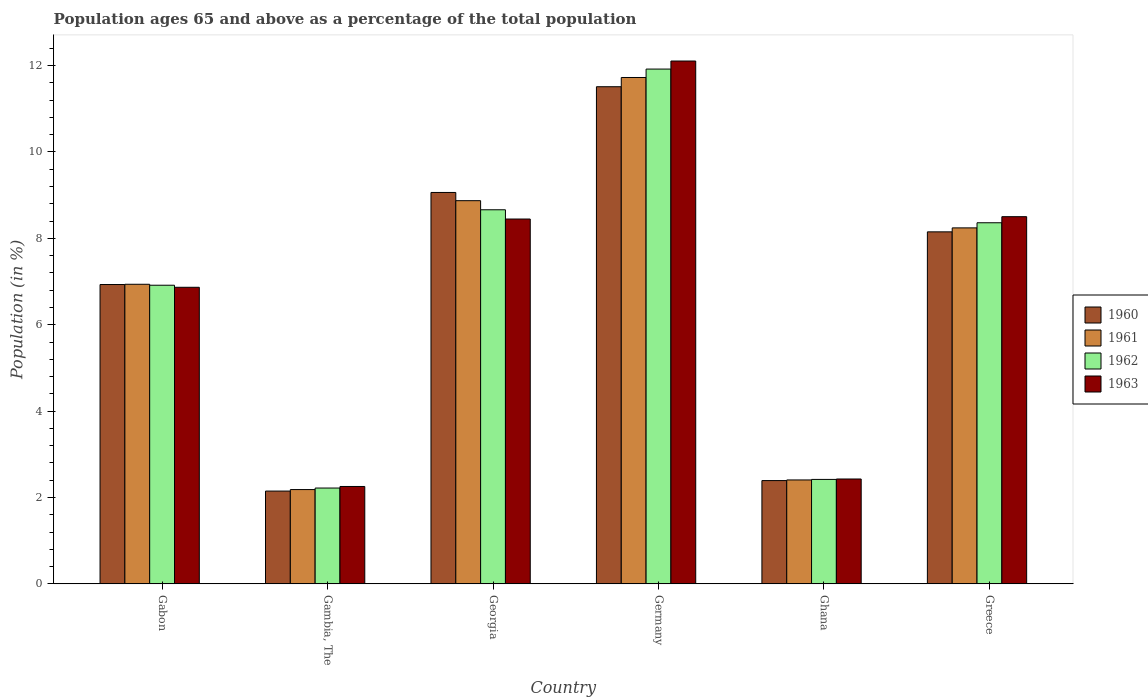Are the number of bars per tick equal to the number of legend labels?
Your response must be concise. Yes. How many bars are there on the 5th tick from the right?
Your response must be concise. 4. What is the label of the 4th group of bars from the left?
Your answer should be very brief. Germany. In how many cases, is the number of bars for a given country not equal to the number of legend labels?
Your answer should be compact. 0. What is the percentage of the population ages 65 and above in 1960 in Gambia, The?
Ensure brevity in your answer.  2.15. Across all countries, what is the maximum percentage of the population ages 65 and above in 1963?
Make the answer very short. 12.11. Across all countries, what is the minimum percentage of the population ages 65 and above in 1963?
Provide a succinct answer. 2.25. In which country was the percentage of the population ages 65 and above in 1963 minimum?
Offer a terse response. Gambia, The. What is the total percentage of the population ages 65 and above in 1960 in the graph?
Ensure brevity in your answer.  40.2. What is the difference between the percentage of the population ages 65 and above in 1960 in Gabon and that in Germany?
Provide a short and direct response. -4.58. What is the difference between the percentage of the population ages 65 and above in 1960 in Gambia, The and the percentage of the population ages 65 and above in 1962 in Ghana?
Your answer should be compact. -0.27. What is the average percentage of the population ages 65 and above in 1962 per country?
Ensure brevity in your answer.  6.75. What is the difference between the percentage of the population ages 65 and above of/in 1961 and percentage of the population ages 65 and above of/in 1962 in Ghana?
Your answer should be compact. -0.01. What is the ratio of the percentage of the population ages 65 and above in 1963 in Gabon to that in Greece?
Provide a succinct answer. 0.81. Is the percentage of the population ages 65 and above in 1961 in Georgia less than that in Ghana?
Provide a succinct answer. No. What is the difference between the highest and the second highest percentage of the population ages 65 and above in 1963?
Make the answer very short. 0.05. What is the difference between the highest and the lowest percentage of the population ages 65 and above in 1963?
Your response must be concise. 9.85. What does the 2nd bar from the left in Ghana represents?
Make the answer very short. 1961. Is it the case that in every country, the sum of the percentage of the population ages 65 and above in 1963 and percentage of the population ages 65 and above in 1962 is greater than the percentage of the population ages 65 and above in 1961?
Your answer should be very brief. Yes. How many bars are there?
Offer a very short reply. 24. How many countries are there in the graph?
Your answer should be very brief. 6. What is the difference between two consecutive major ticks on the Y-axis?
Provide a short and direct response. 2. Are the values on the major ticks of Y-axis written in scientific E-notation?
Provide a succinct answer. No. How many legend labels are there?
Your response must be concise. 4. How are the legend labels stacked?
Your answer should be very brief. Vertical. What is the title of the graph?
Offer a terse response. Population ages 65 and above as a percentage of the total population. What is the label or title of the Y-axis?
Provide a succinct answer. Population (in %). What is the Population (in %) in 1960 in Gabon?
Offer a terse response. 6.93. What is the Population (in %) in 1961 in Gabon?
Keep it short and to the point. 6.94. What is the Population (in %) of 1962 in Gabon?
Your response must be concise. 6.91. What is the Population (in %) in 1963 in Gabon?
Provide a succinct answer. 6.87. What is the Population (in %) in 1960 in Gambia, The?
Make the answer very short. 2.15. What is the Population (in %) of 1961 in Gambia, The?
Give a very brief answer. 2.18. What is the Population (in %) in 1962 in Gambia, The?
Your response must be concise. 2.22. What is the Population (in %) of 1963 in Gambia, The?
Provide a short and direct response. 2.25. What is the Population (in %) of 1960 in Georgia?
Your answer should be compact. 9.06. What is the Population (in %) of 1961 in Georgia?
Your answer should be very brief. 8.87. What is the Population (in %) in 1962 in Georgia?
Your answer should be very brief. 8.66. What is the Population (in %) of 1963 in Georgia?
Provide a short and direct response. 8.45. What is the Population (in %) of 1960 in Germany?
Give a very brief answer. 11.51. What is the Population (in %) in 1961 in Germany?
Ensure brevity in your answer.  11.73. What is the Population (in %) in 1962 in Germany?
Provide a succinct answer. 11.92. What is the Population (in %) of 1963 in Germany?
Keep it short and to the point. 12.11. What is the Population (in %) in 1960 in Ghana?
Ensure brevity in your answer.  2.39. What is the Population (in %) in 1961 in Ghana?
Ensure brevity in your answer.  2.41. What is the Population (in %) in 1962 in Ghana?
Your response must be concise. 2.42. What is the Population (in %) in 1963 in Ghana?
Keep it short and to the point. 2.43. What is the Population (in %) of 1960 in Greece?
Give a very brief answer. 8.15. What is the Population (in %) of 1961 in Greece?
Your answer should be compact. 8.24. What is the Population (in %) of 1962 in Greece?
Ensure brevity in your answer.  8.36. What is the Population (in %) in 1963 in Greece?
Offer a very short reply. 8.5. Across all countries, what is the maximum Population (in %) of 1960?
Ensure brevity in your answer.  11.51. Across all countries, what is the maximum Population (in %) in 1961?
Provide a succinct answer. 11.73. Across all countries, what is the maximum Population (in %) of 1962?
Offer a very short reply. 11.92. Across all countries, what is the maximum Population (in %) of 1963?
Offer a very short reply. 12.11. Across all countries, what is the minimum Population (in %) of 1960?
Provide a short and direct response. 2.15. Across all countries, what is the minimum Population (in %) of 1961?
Keep it short and to the point. 2.18. Across all countries, what is the minimum Population (in %) in 1962?
Your response must be concise. 2.22. Across all countries, what is the minimum Population (in %) in 1963?
Provide a succinct answer. 2.25. What is the total Population (in %) of 1960 in the graph?
Your answer should be very brief. 40.2. What is the total Population (in %) in 1961 in the graph?
Give a very brief answer. 40.37. What is the total Population (in %) of 1962 in the graph?
Your answer should be very brief. 40.5. What is the total Population (in %) of 1963 in the graph?
Ensure brevity in your answer.  40.61. What is the difference between the Population (in %) of 1960 in Gabon and that in Gambia, The?
Your answer should be compact. 4.78. What is the difference between the Population (in %) of 1961 in Gabon and that in Gambia, The?
Offer a terse response. 4.75. What is the difference between the Population (in %) of 1962 in Gabon and that in Gambia, The?
Your answer should be very brief. 4.7. What is the difference between the Population (in %) in 1963 in Gabon and that in Gambia, The?
Ensure brevity in your answer.  4.61. What is the difference between the Population (in %) in 1960 in Gabon and that in Georgia?
Ensure brevity in your answer.  -2.13. What is the difference between the Population (in %) of 1961 in Gabon and that in Georgia?
Provide a short and direct response. -1.94. What is the difference between the Population (in %) in 1962 in Gabon and that in Georgia?
Your answer should be very brief. -1.75. What is the difference between the Population (in %) in 1963 in Gabon and that in Georgia?
Offer a terse response. -1.58. What is the difference between the Population (in %) in 1960 in Gabon and that in Germany?
Provide a short and direct response. -4.58. What is the difference between the Population (in %) of 1961 in Gabon and that in Germany?
Offer a very short reply. -4.79. What is the difference between the Population (in %) in 1962 in Gabon and that in Germany?
Your response must be concise. -5.01. What is the difference between the Population (in %) in 1963 in Gabon and that in Germany?
Make the answer very short. -5.24. What is the difference between the Population (in %) in 1960 in Gabon and that in Ghana?
Provide a short and direct response. 4.54. What is the difference between the Population (in %) of 1961 in Gabon and that in Ghana?
Your answer should be very brief. 4.53. What is the difference between the Population (in %) of 1962 in Gabon and that in Ghana?
Give a very brief answer. 4.5. What is the difference between the Population (in %) in 1963 in Gabon and that in Ghana?
Offer a terse response. 4.44. What is the difference between the Population (in %) of 1960 in Gabon and that in Greece?
Your answer should be very brief. -1.22. What is the difference between the Population (in %) of 1961 in Gabon and that in Greece?
Give a very brief answer. -1.31. What is the difference between the Population (in %) of 1962 in Gabon and that in Greece?
Offer a very short reply. -1.45. What is the difference between the Population (in %) of 1963 in Gabon and that in Greece?
Provide a short and direct response. -1.64. What is the difference between the Population (in %) of 1960 in Gambia, The and that in Georgia?
Offer a very short reply. -6.91. What is the difference between the Population (in %) in 1961 in Gambia, The and that in Georgia?
Provide a short and direct response. -6.69. What is the difference between the Population (in %) of 1962 in Gambia, The and that in Georgia?
Make the answer very short. -6.44. What is the difference between the Population (in %) in 1963 in Gambia, The and that in Georgia?
Your answer should be compact. -6.19. What is the difference between the Population (in %) in 1960 in Gambia, The and that in Germany?
Offer a very short reply. -9.36. What is the difference between the Population (in %) of 1961 in Gambia, The and that in Germany?
Keep it short and to the point. -9.54. What is the difference between the Population (in %) of 1962 in Gambia, The and that in Germany?
Provide a succinct answer. -9.7. What is the difference between the Population (in %) in 1963 in Gambia, The and that in Germany?
Your answer should be very brief. -9.85. What is the difference between the Population (in %) of 1960 in Gambia, The and that in Ghana?
Your answer should be very brief. -0.24. What is the difference between the Population (in %) of 1961 in Gambia, The and that in Ghana?
Give a very brief answer. -0.22. What is the difference between the Population (in %) of 1962 in Gambia, The and that in Ghana?
Offer a terse response. -0.2. What is the difference between the Population (in %) of 1963 in Gambia, The and that in Ghana?
Your answer should be compact. -0.17. What is the difference between the Population (in %) of 1960 in Gambia, The and that in Greece?
Provide a succinct answer. -6. What is the difference between the Population (in %) in 1961 in Gambia, The and that in Greece?
Make the answer very short. -6.06. What is the difference between the Population (in %) of 1962 in Gambia, The and that in Greece?
Offer a very short reply. -6.14. What is the difference between the Population (in %) of 1963 in Gambia, The and that in Greece?
Make the answer very short. -6.25. What is the difference between the Population (in %) of 1960 in Georgia and that in Germany?
Provide a short and direct response. -2.45. What is the difference between the Population (in %) of 1961 in Georgia and that in Germany?
Your answer should be very brief. -2.85. What is the difference between the Population (in %) in 1962 in Georgia and that in Germany?
Offer a very short reply. -3.26. What is the difference between the Population (in %) of 1963 in Georgia and that in Germany?
Make the answer very short. -3.66. What is the difference between the Population (in %) in 1960 in Georgia and that in Ghana?
Give a very brief answer. 6.67. What is the difference between the Population (in %) in 1961 in Georgia and that in Ghana?
Your answer should be compact. 6.47. What is the difference between the Population (in %) in 1962 in Georgia and that in Ghana?
Your response must be concise. 6.24. What is the difference between the Population (in %) of 1963 in Georgia and that in Ghana?
Keep it short and to the point. 6.02. What is the difference between the Population (in %) in 1960 in Georgia and that in Greece?
Provide a short and direct response. 0.91. What is the difference between the Population (in %) in 1961 in Georgia and that in Greece?
Make the answer very short. 0.63. What is the difference between the Population (in %) of 1962 in Georgia and that in Greece?
Give a very brief answer. 0.3. What is the difference between the Population (in %) of 1963 in Georgia and that in Greece?
Your answer should be very brief. -0.05. What is the difference between the Population (in %) in 1960 in Germany and that in Ghana?
Offer a terse response. 9.12. What is the difference between the Population (in %) in 1961 in Germany and that in Ghana?
Keep it short and to the point. 9.32. What is the difference between the Population (in %) in 1962 in Germany and that in Ghana?
Give a very brief answer. 9.5. What is the difference between the Population (in %) in 1963 in Germany and that in Ghana?
Ensure brevity in your answer.  9.68. What is the difference between the Population (in %) in 1960 in Germany and that in Greece?
Your response must be concise. 3.36. What is the difference between the Population (in %) of 1961 in Germany and that in Greece?
Offer a terse response. 3.48. What is the difference between the Population (in %) of 1962 in Germany and that in Greece?
Your response must be concise. 3.56. What is the difference between the Population (in %) in 1963 in Germany and that in Greece?
Provide a short and direct response. 3.6. What is the difference between the Population (in %) in 1960 in Ghana and that in Greece?
Your response must be concise. -5.76. What is the difference between the Population (in %) of 1961 in Ghana and that in Greece?
Provide a succinct answer. -5.84. What is the difference between the Population (in %) of 1962 in Ghana and that in Greece?
Your response must be concise. -5.94. What is the difference between the Population (in %) in 1963 in Ghana and that in Greece?
Your answer should be compact. -6.07. What is the difference between the Population (in %) in 1960 in Gabon and the Population (in %) in 1961 in Gambia, The?
Make the answer very short. 4.75. What is the difference between the Population (in %) in 1960 in Gabon and the Population (in %) in 1962 in Gambia, The?
Offer a very short reply. 4.71. What is the difference between the Population (in %) in 1960 in Gabon and the Population (in %) in 1963 in Gambia, The?
Your answer should be very brief. 4.68. What is the difference between the Population (in %) in 1961 in Gabon and the Population (in %) in 1962 in Gambia, The?
Provide a short and direct response. 4.72. What is the difference between the Population (in %) of 1961 in Gabon and the Population (in %) of 1963 in Gambia, The?
Offer a terse response. 4.68. What is the difference between the Population (in %) in 1962 in Gabon and the Population (in %) in 1963 in Gambia, The?
Your answer should be compact. 4.66. What is the difference between the Population (in %) of 1960 in Gabon and the Population (in %) of 1961 in Georgia?
Offer a very short reply. -1.94. What is the difference between the Population (in %) in 1960 in Gabon and the Population (in %) in 1962 in Georgia?
Your answer should be compact. -1.73. What is the difference between the Population (in %) in 1960 in Gabon and the Population (in %) in 1963 in Georgia?
Keep it short and to the point. -1.52. What is the difference between the Population (in %) in 1961 in Gabon and the Population (in %) in 1962 in Georgia?
Your answer should be compact. -1.73. What is the difference between the Population (in %) in 1961 in Gabon and the Population (in %) in 1963 in Georgia?
Your response must be concise. -1.51. What is the difference between the Population (in %) in 1962 in Gabon and the Population (in %) in 1963 in Georgia?
Ensure brevity in your answer.  -1.53. What is the difference between the Population (in %) in 1960 in Gabon and the Population (in %) in 1961 in Germany?
Ensure brevity in your answer.  -4.79. What is the difference between the Population (in %) in 1960 in Gabon and the Population (in %) in 1962 in Germany?
Offer a very short reply. -4.99. What is the difference between the Population (in %) in 1960 in Gabon and the Population (in %) in 1963 in Germany?
Your answer should be very brief. -5.18. What is the difference between the Population (in %) of 1961 in Gabon and the Population (in %) of 1962 in Germany?
Provide a short and direct response. -4.98. What is the difference between the Population (in %) of 1961 in Gabon and the Population (in %) of 1963 in Germany?
Keep it short and to the point. -5.17. What is the difference between the Population (in %) of 1962 in Gabon and the Population (in %) of 1963 in Germany?
Keep it short and to the point. -5.19. What is the difference between the Population (in %) in 1960 in Gabon and the Population (in %) in 1961 in Ghana?
Provide a succinct answer. 4.53. What is the difference between the Population (in %) of 1960 in Gabon and the Population (in %) of 1962 in Ghana?
Offer a very short reply. 4.51. What is the difference between the Population (in %) in 1960 in Gabon and the Population (in %) in 1963 in Ghana?
Ensure brevity in your answer.  4.5. What is the difference between the Population (in %) of 1961 in Gabon and the Population (in %) of 1962 in Ghana?
Provide a short and direct response. 4.52. What is the difference between the Population (in %) of 1961 in Gabon and the Population (in %) of 1963 in Ghana?
Provide a short and direct response. 4.51. What is the difference between the Population (in %) in 1962 in Gabon and the Population (in %) in 1963 in Ghana?
Your response must be concise. 4.49. What is the difference between the Population (in %) of 1960 in Gabon and the Population (in %) of 1961 in Greece?
Offer a terse response. -1.31. What is the difference between the Population (in %) in 1960 in Gabon and the Population (in %) in 1962 in Greece?
Ensure brevity in your answer.  -1.43. What is the difference between the Population (in %) of 1960 in Gabon and the Population (in %) of 1963 in Greece?
Give a very brief answer. -1.57. What is the difference between the Population (in %) in 1961 in Gabon and the Population (in %) in 1962 in Greece?
Keep it short and to the point. -1.42. What is the difference between the Population (in %) of 1961 in Gabon and the Population (in %) of 1963 in Greece?
Keep it short and to the point. -1.57. What is the difference between the Population (in %) in 1962 in Gabon and the Population (in %) in 1963 in Greece?
Keep it short and to the point. -1.59. What is the difference between the Population (in %) of 1960 in Gambia, The and the Population (in %) of 1961 in Georgia?
Give a very brief answer. -6.72. What is the difference between the Population (in %) of 1960 in Gambia, The and the Population (in %) of 1962 in Georgia?
Keep it short and to the point. -6.51. What is the difference between the Population (in %) of 1960 in Gambia, The and the Population (in %) of 1963 in Georgia?
Offer a very short reply. -6.3. What is the difference between the Population (in %) in 1961 in Gambia, The and the Population (in %) in 1962 in Georgia?
Provide a succinct answer. -6.48. What is the difference between the Population (in %) of 1961 in Gambia, The and the Population (in %) of 1963 in Georgia?
Make the answer very short. -6.26. What is the difference between the Population (in %) in 1962 in Gambia, The and the Population (in %) in 1963 in Georgia?
Offer a very short reply. -6.23. What is the difference between the Population (in %) in 1960 in Gambia, The and the Population (in %) in 1961 in Germany?
Make the answer very short. -9.58. What is the difference between the Population (in %) in 1960 in Gambia, The and the Population (in %) in 1962 in Germany?
Keep it short and to the point. -9.77. What is the difference between the Population (in %) of 1960 in Gambia, The and the Population (in %) of 1963 in Germany?
Your answer should be very brief. -9.96. What is the difference between the Population (in %) of 1961 in Gambia, The and the Population (in %) of 1962 in Germany?
Give a very brief answer. -9.74. What is the difference between the Population (in %) of 1961 in Gambia, The and the Population (in %) of 1963 in Germany?
Your answer should be very brief. -9.92. What is the difference between the Population (in %) of 1962 in Gambia, The and the Population (in %) of 1963 in Germany?
Offer a terse response. -9.89. What is the difference between the Population (in %) in 1960 in Gambia, The and the Population (in %) in 1961 in Ghana?
Your answer should be compact. -0.26. What is the difference between the Population (in %) of 1960 in Gambia, The and the Population (in %) of 1962 in Ghana?
Offer a terse response. -0.27. What is the difference between the Population (in %) of 1960 in Gambia, The and the Population (in %) of 1963 in Ghana?
Your response must be concise. -0.28. What is the difference between the Population (in %) of 1961 in Gambia, The and the Population (in %) of 1962 in Ghana?
Your response must be concise. -0.24. What is the difference between the Population (in %) in 1961 in Gambia, The and the Population (in %) in 1963 in Ghana?
Provide a short and direct response. -0.24. What is the difference between the Population (in %) in 1962 in Gambia, The and the Population (in %) in 1963 in Ghana?
Make the answer very short. -0.21. What is the difference between the Population (in %) in 1960 in Gambia, The and the Population (in %) in 1961 in Greece?
Make the answer very short. -6.09. What is the difference between the Population (in %) of 1960 in Gambia, The and the Population (in %) of 1962 in Greece?
Provide a succinct answer. -6.21. What is the difference between the Population (in %) in 1960 in Gambia, The and the Population (in %) in 1963 in Greece?
Offer a terse response. -6.35. What is the difference between the Population (in %) in 1961 in Gambia, The and the Population (in %) in 1962 in Greece?
Ensure brevity in your answer.  -6.18. What is the difference between the Population (in %) in 1961 in Gambia, The and the Population (in %) in 1963 in Greece?
Give a very brief answer. -6.32. What is the difference between the Population (in %) in 1962 in Gambia, The and the Population (in %) in 1963 in Greece?
Provide a succinct answer. -6.28. What is the difference between the Population (in %) of 1960 in Georgia and the Population (in %) of 1961 in Germany?
Give a very brief answer. -2.66. What is the difference between the Population (in %) in 1960 in Georgia and the Population (in %) in 1962 in Germany?
Your response must be concise. -2.86. What is the difference between the Population (in %) of 1960 in Georgia and the Population (in %) of 1963 in Germany?
Provide a short and direct response. -3.04. What is the difference between the Population (in %) in 1961 in Georgia and the Population (in %) in 1962 in Germany?
Ensure brevity in your answer.  -3.05. What is the difference between the Population (in %) of 1961 in Georgia and the Population (in %) of 1963 in Germany?
Offer a very short reply. -3.23. What is the difference between the Population (in %) of 1962 in Georgia and the Population (in %) of 1963 in Germany?
Provide a short and direct response. -3.44. What is the difference between the Population (in %) of 1960 in Georgia and the Population (in %) of 1961 in Ghana?
Ensure brevity in your answer.  6.66. What is the difference between the Population (in %) of 1960 in Georgia and the Population (in %) of 1962 in Ghana?
Keep it short and to the point. 6.64. What is the difference between the Population (in %) in 1960 in Georgia and the Population (in %) in 1963 in Ghana?
Offer a very short reply. 6.63. What is the difference between the Population (in %) in 1961 in Georgia and the Population (in %) in 1962 in Ghana?
Offer a terse response. 6.45. What is the difference between the Population (in %) in 1961 in Georgia and the Population (in %) in 1963 in Ghana?
Provide a short and direct response. 6.44. What is the difference between the Population (in %) of 1962 in Georgia and the Population (in %) of 1963 in Ghana?
Offer a very short reply. 6.23. What is the difference between the Population (in %) of 1960 in Georgia and the Population (in %) of 1961 in Greece?
Provide a short and direct response. 0.82. What is the difference between the Population (in %) of 1960 in Georgia and the Population (in %) of 1962 in Greece?
Ensure brevity in your answer.  0.7. What is the difference between the Population (in %) in 1960 in Georgia and the Population (in %) in 1963 in Greece?
Provide a succinct answer. 0.56. What is the difference between the Population (in %) of 1961 in Georgia and the Population (in %) of 1962 in Greece?
Ensure brevity in your answer.  0.51. What is the difference between the Population (in %) in 1961 in Georgia and the Population (in %) in 1963 in Greece?
Provide a succinct answer. 0.37. What is the difference between the Population (in %) in 1962 in Georgia and the Population (in %) in 1963 in Greece?
Provide a short and direct response. 0.16. What is the difference between the Population (in %) in 1960 in Germany and the Population (in %) in 1961 in Ghana?
Offer a very short reply. 9.11. What is the difference between the Population (in %) in 1960 in Germany and the Population (in %) in 1962 in Ghana?
Provide a succinct answer. 9.09. What is the difference between the Population (in %) of 1960 in Germany and the Population (in %) of 1963 in Ghana?
Give a very brief answer. 9.08. What is the difference between the Population (in %) in 1961 in Germany and the Population (in %) in 1962 in Ghana?
Your response must be concise. 9.31. What is the difference between the Population (in %) in 1961 in Germany and the Population (in %) in 1963 in Ghana?
Your answer should be compact. 9.3. What is the difference between the Population (in %) of 1962 in Germany and the Population (in %) of 1963 in Ghana?
Offer a very short reply. 9.49. What is the difference between the Population (in %) of 1960 in Germany and the Population (in %) of 1961 in Greece?
Your answer should be very brief. 3.27. What is the difference between the Population (in %) in 1960 in Germany and the Population (in %) in 1962 in Greece?
Provide a short and direct response. 3.15. What is the difference between the Population (in %) of 1960 in Germany and the Population (in %) of 1963 in Greece?
Your response must be concise. 3.01. What is the difference between the Population (in %) in 1961 in Germany and the Population (in %) in 1962 in Greece?
Provide a succinct answer. 3.36. What is the difference between the Population (in %) of 1961 in Germany and the Population (in %) of 1963 in Greece?
Provide a short and direct response. 3.22. What is the difference between the Population (in %) in 1962 in Germany and the Population (in %) in 1963 in Greece?
Provide a short and direct response. 3.42. What is the difference between the Population (in %) of 1960 in Ghana and the Population (in %) of 1961 in Greece?
Keep it short and to the point. -5.85. What is the difference between the Population (in %) in 1960 in Ghana and the Population (in %) in 1962 in Greece?
Your response must be concise. -5.97. What is the difference between the Population (in %) of 1960 in Ghana and the Population (in %) of 1963 in Greece?
Keep it short and to the point. -6.11. What is the difference between the Population (in %) of 1961 in Ghana and the Population (in %) of 1962 in Greece?
Your response must be concise. -5.96. What is the difference between the Population (in %) in 1961 in Ghana and the Population (in %) in 1963 in Greece?
Offer a terse response. -6.1. What is the difference between the Population (in %) of 1962 in Ghana and the Population (in %) of 1963 in Greece?
Provide a succinct answer. -6.08. What is the average Population (in %) of 1960 per country?
Provide a succinct answer. 6.7. What is the average Population (in %) in 1961 per country?
Keep it short and to the point. 6.73. What is the average Population (in %) in 1962 per country?
Your answer should be very brief. 6.75. What is the average Population (in %) in 1963 per country?
Your answer should be very brief. 6.77. What is the difference between the Population (in %) in 1960 and Population (in %) in 1961 in Gabon?
Ensure brevity in your answer.  -0.01. What is the difference between the Population (in %) in 1960 and Population (in %) in 1962 in Gabon?
Your answer should be very brief. 0.02. What is the difference between the Population (in %) in 1960 and Population (in %) in 1963 in Gabon?
Keep it short and to the point. 0.06. What is the difference between the Population (in %) in 1961 and Population (in %) in 1962 in Gabon?
Offer a terse response. 0.02. What is the difference between the Population (in %) in 1961 and Population (in %) in 1963 in Gabon?
Keep it short and to the point. 0.07. What is the difference between the Population (in %) in 1962 and Population (in %) in 1963 in Gabon?
Ensure brevity in your answer.  0.05. What is the difference between the Population (in %) in 1960 and Population (in %) in 1961 in Gambia, The?
Ensure brevity in your answer.  -0.03. What is the difference between the Population (in %) in 1960 and Population (in %) in 1962 in Gambia, The?
Your answer should be compact. -0.07. What is the difference between the Population (in %) in 1960 and Population (in %) in 1963 in Gambia, The?
Offer a very short reply. -0.11. What is the difference between the Population (in %) of 1961 and Population (in %) of 1962 in Gambia, The?
Give a very brief answer. -0.04. What is the difference between the Population (in %) of 1961 and Population (in %) of 1963 in Gambia, The?
Provide a succinct answer. -0.07. What is the difference between the Population (in %) in 1962 and Population (in %) in 1963 in Gambia, The?
Make the answer very short. -0.04. What is the difference between the Population (in %) in 1960 and Population (in %) in 1961 in Georgia?
Offer a very short reply. 0.19. What is the difference between the Population (in %) of 1960 and Population (in %) of 1962 in Georgia?
Ensure brevity in your answer.  0.4. What is the difference between the Population (in %) of 1960 and Population (in %) of 1963 in Georgia?
Your answer should be very brief. 0.61. What is the difference between the Population (in %) of 1961 and Population (in %) of 1962 in Georgia?
Ensure brevity in your answer.  0.21. What is the difference between the Population (in %) in 1961 and Population (in %) in 1963 in Georgia?
Give a very brief answer. 0.42. What is the difference between the Population (in %) of 1962 and Population (in %) of 1963 in Georgia?
Provide a succinct answer. 0.21. What is the difference between the Population (in %) of 1960 and Population (in %) of 1961 in Germany?
Provide a short and direct response. -0.21. What is the difference between the Population (in %) of 1960 and Population (in %) of 1962 in Germany?
Keep it short and to the point. -0.41. What is the difference between the Population (in %) of 1960 and Population (in %) of 1963 in Germany?
Make the answer very short. -0.6. What is the difference between the Population (in %) in 1961 and Population (in %) in 1962 in Germany?
Provide a succinct answer. -0.2. What is the difference between the Population (in %) of 1961 and Population (in %) of 1963 in Germany?
Provide a short and direct response. -0.38. What is the difference between the Population (in %) of 1962 and Population (in %) of 1963 in Germany?
Offer a terse response. -0.19. What is the difference between the Population (in %) in 1960 and Population (in %) in 1961 in Ghana?
Your answer should be compact. -0.01. What is the difference between the Population (in %) in 1960 and Population (in %) in 1962 in Ghana?
Ensure brevity in your answer.  -0.03. What is the difference between the Population (in %) in 1960 and Population (in %) in 1963 in Ghana?
Give a very brief answer. -0.04. What is the difference between the Population (in %) of 1961 and Population (in %) of 1962 in Ghana?
Your response must be concise. -0.01. What is the difference between the Population (in %) in 1961 and Population (in %) in 1963 in Ghana?
Ensure brevity in your answer.  -0.02. What is the difference between the Population (in %) of 1962 and Population (in %) of 1963 in Ghana?
Make the answer very short. -0.01. What is the difference between the Population (in %) of 1960 and Population (in %) of 1961 in Greece?
Ensure brevity in your answer.  -0.09. What is the difference between the Population (in %) in 1960 and Population (in %) in 1962 in Greece?
Your answer should be very brief. -0.21. What is the difference between the Population (in %) of 1960 and Population (in %) of 1963 in Greece?
Ensure brevity in your answer.  -0.35. What is the difference between the Population (in %) of 1961 and Population (in %) of 1962 in Greece?
Offer a terse response. -0.12. What is the difference between the Population (in %) in 1961 and Population (in %) in 1963 in Greece?
Your response must be concise. -0.26. What is the difference between the Population (in %) in 1962 and Population (in %) in 1963 in Greece?
Make the answer very short. -0.14. What is the ratio of the Population (in %) in 1960 in Gabon to that in Gambia, The?
Your answer should be compact. 3.23. What is the ratio of the Population (in %) of 1961 in Gabon to that in Gambia, The?
Offer a very short reply. 3.18. What is the ratio of the Population (in %) of 1962 in Gabon to that in Gambia, The?
Give a very brief answer. 3.12. What is the ratio of the Population (in %) of 1963 in Gabon to that in Gambia, The?
Your response must be concise. 3.05. What is the ratio of the Population (in %) of 1960 in Gabon to that in Georgia?
Offer a very short reply. 0.76. What is the ratio of the Population (in %) in 1961 in Gabon to that in Georgia?
Your answer should be very brief. 0.78. What is the ratio of the Population (in %) in 1962 in Gabon to that in Georgia?
Your response must be concise. 0.8. What is the ratio of the Population (in %) of 1963 in Gabon to that in Georgia?
Your answer should be very brief. 0.81. What is the ratio of the Population (in %) in 1960 in Gabon to that in Germany?
Your answer should be very brief. 0.6. What is the ratio of the Population (in %) in 1961 in Gabon to that in Germany?
Provide a short and direct response. 0.59. What is the ratio of the Population (in %) of 1962 in Gabon to that in Germany?
Your answer should be compact. 0.58. What is the ratio of the Population (in %) in 1963 in Gabon to that in Germany?
Your answer should be compact. 0.57. What is the ratio of the Population (in %) in 1960 in Gabon to that in Ghana?
Make the answer very short. 2.9. What is the ratio of the Population (in %) in 1961 in Gabon to that in Ghana?
Keep it short and to the point. 2.88. What is the ratio of the Population (in %) in 1962 in Gabon to that in Ghana?
Your answer should be very brief. 2.86. What is the ratio of the Population (in %) of 1963 in Gabon to that in Ghana?
Give a very brief answer. 2.83. What is the ratio of the Population (in %) of 1960 in Gabon to that in Greece?
Your answer should be compact. 0.85. What is the ratio of the Population (in %) in 1961 in Gabon to that in Greece?
Your answer should be compact. 0.84. What is the ratio of the Population (in %) in 1962 in Gabon to that in Greece?
Give a very brief answer. 0.83. What is the ratio of the Population (in %) of 1963 in Gabon to that in Greece?
Your response must be concise. 0.81. What is the ratio of the Population (in %) in 1960 in Gambia, The to that in Georgia?
Keep it short and to the point. 0.24. What is the ratio of the Population (in %) in 1961 in Gambia, The to that in Georgia?
Keep it short and to the point. 0.25. What is the ratio of the Population (in %) of 1962 in Gambia, The to that in Georgia?
Ensure brevity in your answer.  0.26. What is the ratio of the Population (in %) in 1963 in Gambia, The to that in Georgia?
Ensure brevity in your answer.  0.27. What is the ratio of the Population (in %) of 1960 in Gambia, The to that in Germany?
Provide a succinct answer. 0.19. What is the ratio of the Population (in %) of 1961 in Gambia, The to that in Germany?
Offer a terse response. 0.19. What is the ratio of the Population (in %) in 1962 in Gambia, The to that in Germany?
Give a very brief answer. 0.19. What is the ratio of the Population (in %) in 1963 in Gambia, The to that in Germany?
Provide a succinct answer. 0.19. What is the ratio of the Population (in %) in 1960 in Gambia, The to that in Ghana?
Your answer should be compact. 0.9. What is the ratio of the Population (in %) of 1961 in Gambia, The to that in Ghana?
Make the answer very short. 0.91. What is the ratio of the Population (in %) in 1962 in Gambia, The to that in Ghana?
Give a very brief answer. 0.92. What is the ratio of the Population (in %) of 1963 in Gambia, The to that in Ghana?
Ensure brevity in your answer.  0.93. What is the ratio of the Population (in %) of 1960 in Gambia, The to that in Greece?
Give a very brief answer. 0.26. What is the ratio of the Population (in %) of 1961 in Gambia, The to that in Greece?
Make the answer very short. 0.26. What is the ratio of the Population (in %) of 1962 in Gambia, The to that in Greece?
Keep it short and to the point. 0.27. What is the ratio of the Population (in %) of 1963 in Gambia, The to that in Greece?
Your response must be concise. 0.27. What is the ratio of the Population (in %) of 1960 in Georgia to that in Germany?
Provide a short and direct response. 0.79. What is the ratio of the Population (in %) in 1961 in Georgia to that in Germany?
Give a very brief answer. 0.76. What is the ratio of the Population (in %) in 1962 in Georgia to that in Germany?
Offer a very short reply. 0.73. What is the ratio of the Population (in %) of 1963 in Georgia to that in Germany?
Make the answer very short. 0.7. What is the ratio of the Population (in %) in 1960 in Georgia to that in Ghana?
Your answer should be compact. 3.79. What is the ratio of the Population (in %) of 1961 in Georgia to that in Ghana?
Your answer should be very brief. 3.69. What is the ratio of the Population (in %) in 1962 in Georgia to that in Ghana?
Your answer should be compact. 3.58. What is the ratio of the Population (in %) in 1963 in Georgia to that in Ghana?
Ensure brevity in your answer.  3.48. What is the ratio of the Population (in %) in 1960 in Georgia to that in Greece?
Your answer should be compact. 1.11. What is the ratio of the Population (in %) of 1961 in Georgia to that in Greece?
Your answer should be compact. 1.08. What is the ratio of the Population (in %) in 1962 in Georgia to that in Greece?
Make the answer very short. 1.04. What is the ratio of the Population (in %) in 1963 in Georgia to that in Greece?
Your response must be concise. 0.99. What is the ratio of the Population (in %) in 1960 in Germany to that in Ghana?
Offer a terse response. 4.81. What is the ratio of the Population (in %) in 1961 in Germany to that in Ghana?
Offer a very short reply. 4.87. What is the ratio of the Population (in %) of 1962 in Germany to that in Ghana?
Your answer should be very brief. 4.93. What is the ratio of the Population (in %) of 1963 in Germany to that in Ghana?
Provide a succinct answer. 4.99. What is the ratio of the Population (in %) of 1960 in Germany to that in Greece?
Keep it short and to the point. 1.41. What is the ratio of the Population (in %) of 1961 in Germany to that in Greece?
Give a very brief answer. 1.42. What is the ratio of the Population (in %) in 1962 in Germany to that in Greece?
Your response must be concise. 1.43. What is the ratio of the Population (in %) of 1963 in Germany to that in Greece?
Your answer should be very brief. 1.42. What is the ratio of the Population (in %) in 1960 in Ghana to that in Greece?
Offer a very short reply. 0.29. What is the ratio of the Population (in %) in 1961 in Ghana to that in Greece?
Provide a succinct answer. 0.29. What is the ratio of the Population (in %) in 1962 in Ghana to that in Greece?
Keep it short and to the point. 0.29. What is the ratio of the Population (in %) in 1963 in Ghana to that in Greece?
Offer a terse response. 0.29. What is the difference between the highest and the second highest Population (in %) of 1960?
Your response must be concise. 2.45. What is the difference between the highest and the second highest Population (in %) of 1961?
Ensure brevity in your answer.  2.85. What is the difference between the highest and the second highest Population (in %) of 1962?
Offer a terse response. 3.26. What is the difference between the highest and the second highest Population (in %) in 1963?
Give a very brief answer. 3.6. What is the difference between the highest and the lowest Population (in %) in 1960?
Your answer should be compact. 9.36. What is the difference between the highest and the lowest Population (in %) of 1961?
Provide a short and direct response. 9.54. What is the difference between the highest and the lowest Population (in %) of 1962?
Provide a short and direct response. 9.7. What is the difference between the highest and the lowest Population (in %) in 1963?
Offer a very short reply. 9.85. 